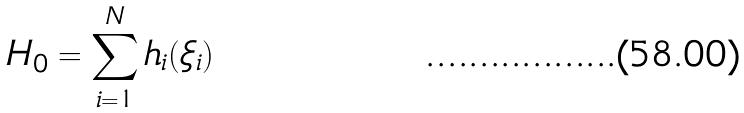<formula> <loc_0><loc_0><loc_500><loc_500>H _ { 0 } = \sum _ { i = 1 } ^ { N } h _ { i } ( \xi _ { i } )</formula> 